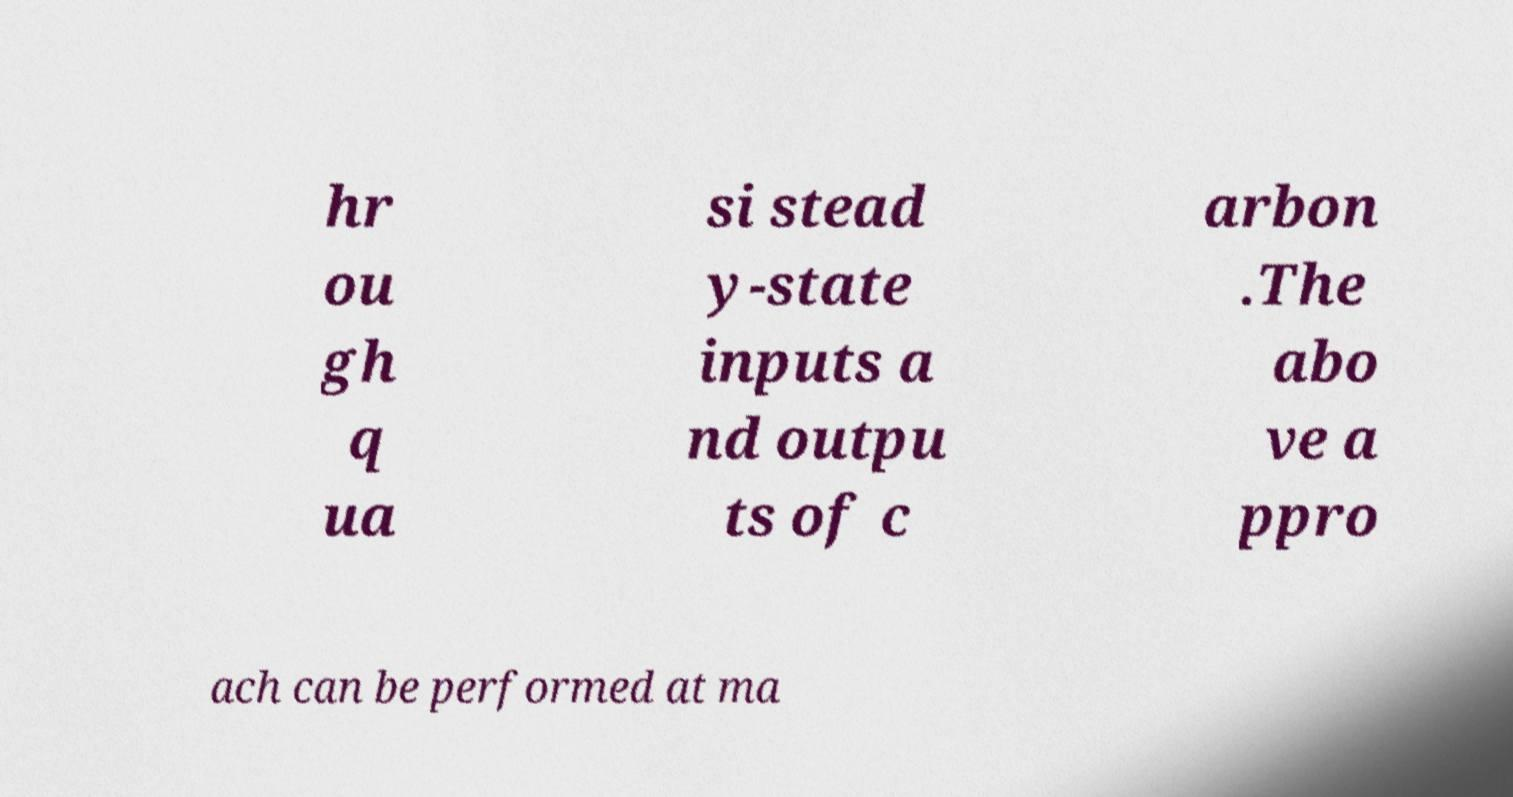I need the written content from this picture converted into text. Can you do that? hr ou gh q ua si stead y-state inputs a nd outpu ts of c arbon .The abo ve a ppro ach can be performed at ma 